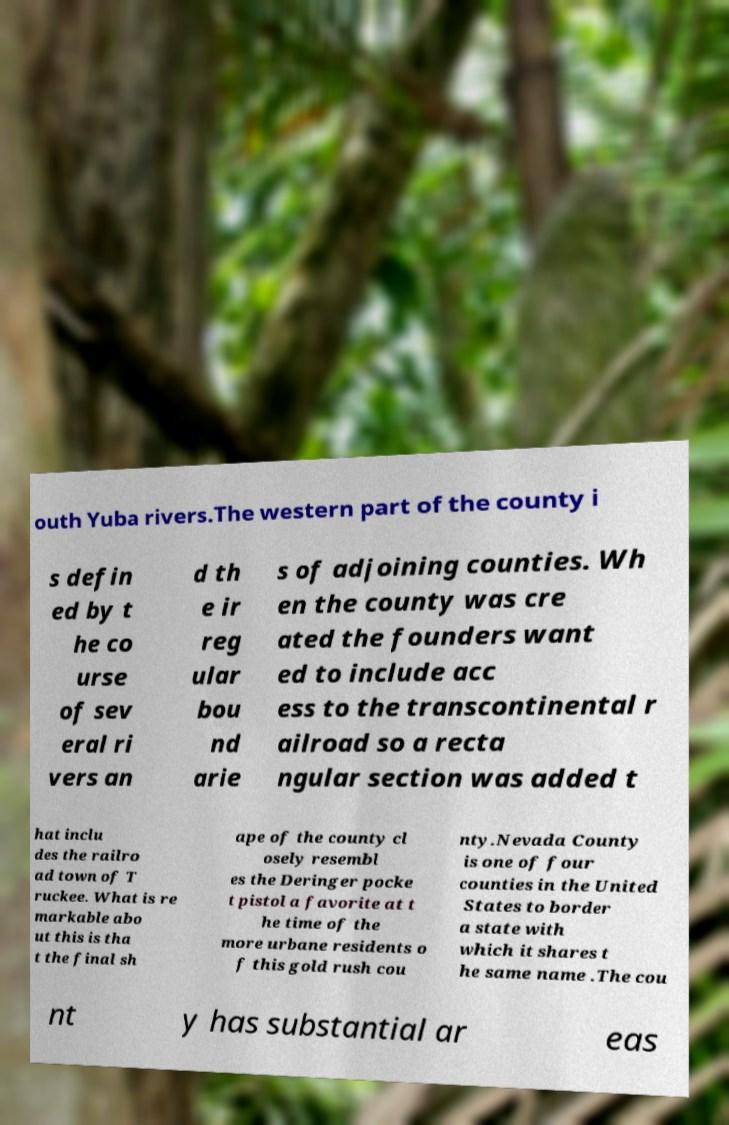Can you read and provide the text displayed in the image?This photo seems to have some interesting text. Can you extract and type it out for me? outh Yuba rivers.The western part of the county i s defin ed by t he co urse of sev eral ri vers an d th e ir reg ular bou nd arie s of adjoining counties. Wh en the county was cre ated the founders want ed to include acc ess to the transcontinental r ailroad so a recta ngular section was added t hat inclu des the railro ad town of T ruckee. What is re markable abo ut this is tha t the final sh ape of the county cl osely resembl es the Deringer pocke t pistol a favorite at t he time of the more urbane residents o f this gold rush cou nty.Nevada County is one of four counties in the United States to border a state with which it shares t he same name .The cou nt y has substantial ar eas 